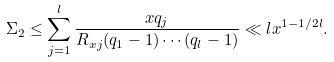<formula> <loc_0><loc_0><loc_500><loc_500>\Sigma _ { 2 } \leq \sum _ { j = 1 } ^ { l } \frac { x q _ { j } } { R _ { x j } ( q _ { 1 } - 1 ) \cdots ( q _ { l } - 1 ) } \ll l x ^ { 1 - 1 / 2 l } .</formula> 